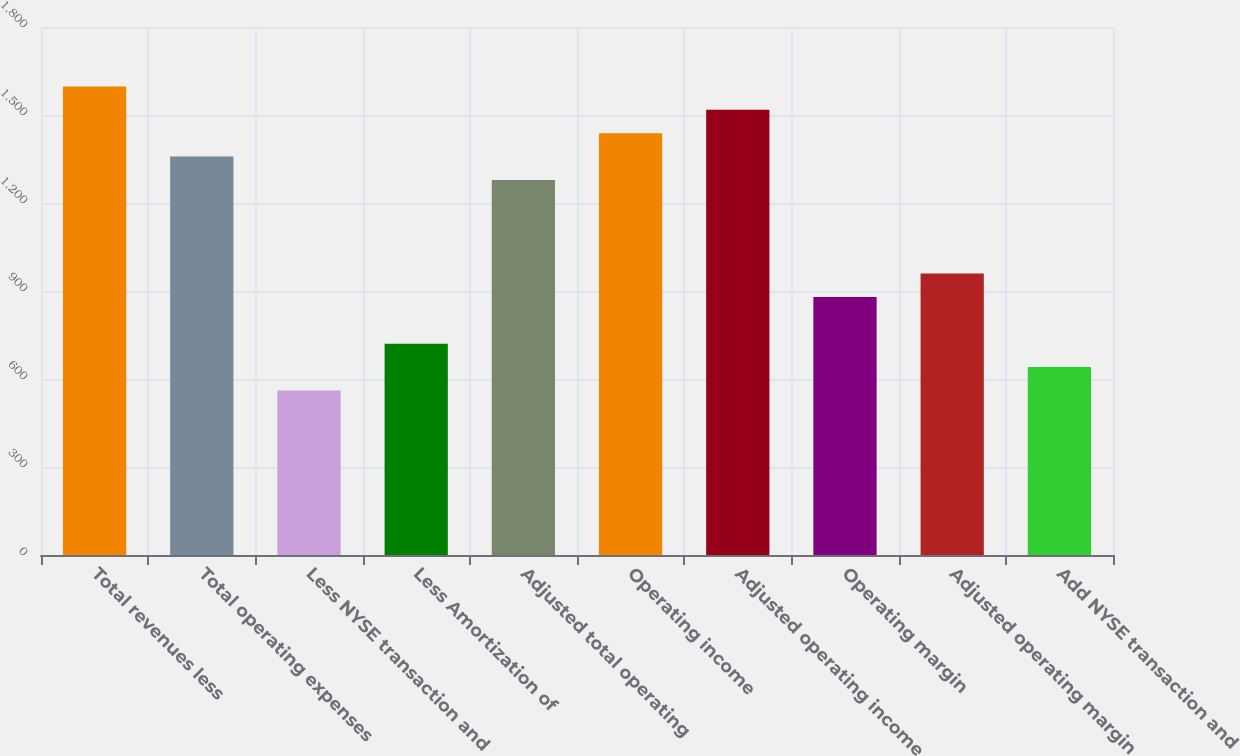<chart> <loc_0><loc_0><loc_500><loc_500><bar_chart><fcel>Total revenues less<fcel>Total operating expenses<fcel>Less NYSE transaction and<fcel>Less Amortization of<fcel>Adjusted total operating<fcel>Operating income<fcel>Adjusted operating income<fcel>Operating margin<fcel>Adjusted operating margin<fcel>Add NYSE transaction and<nl><fcel>1597.54<fcel>1358.29<fcel>560.79<fcel>720.29<fcel>1278.54<fcel>1438.04<fcel>1517.79<fcel>879.79<fcel>959.54<fcel>640.54<nl></chart> 